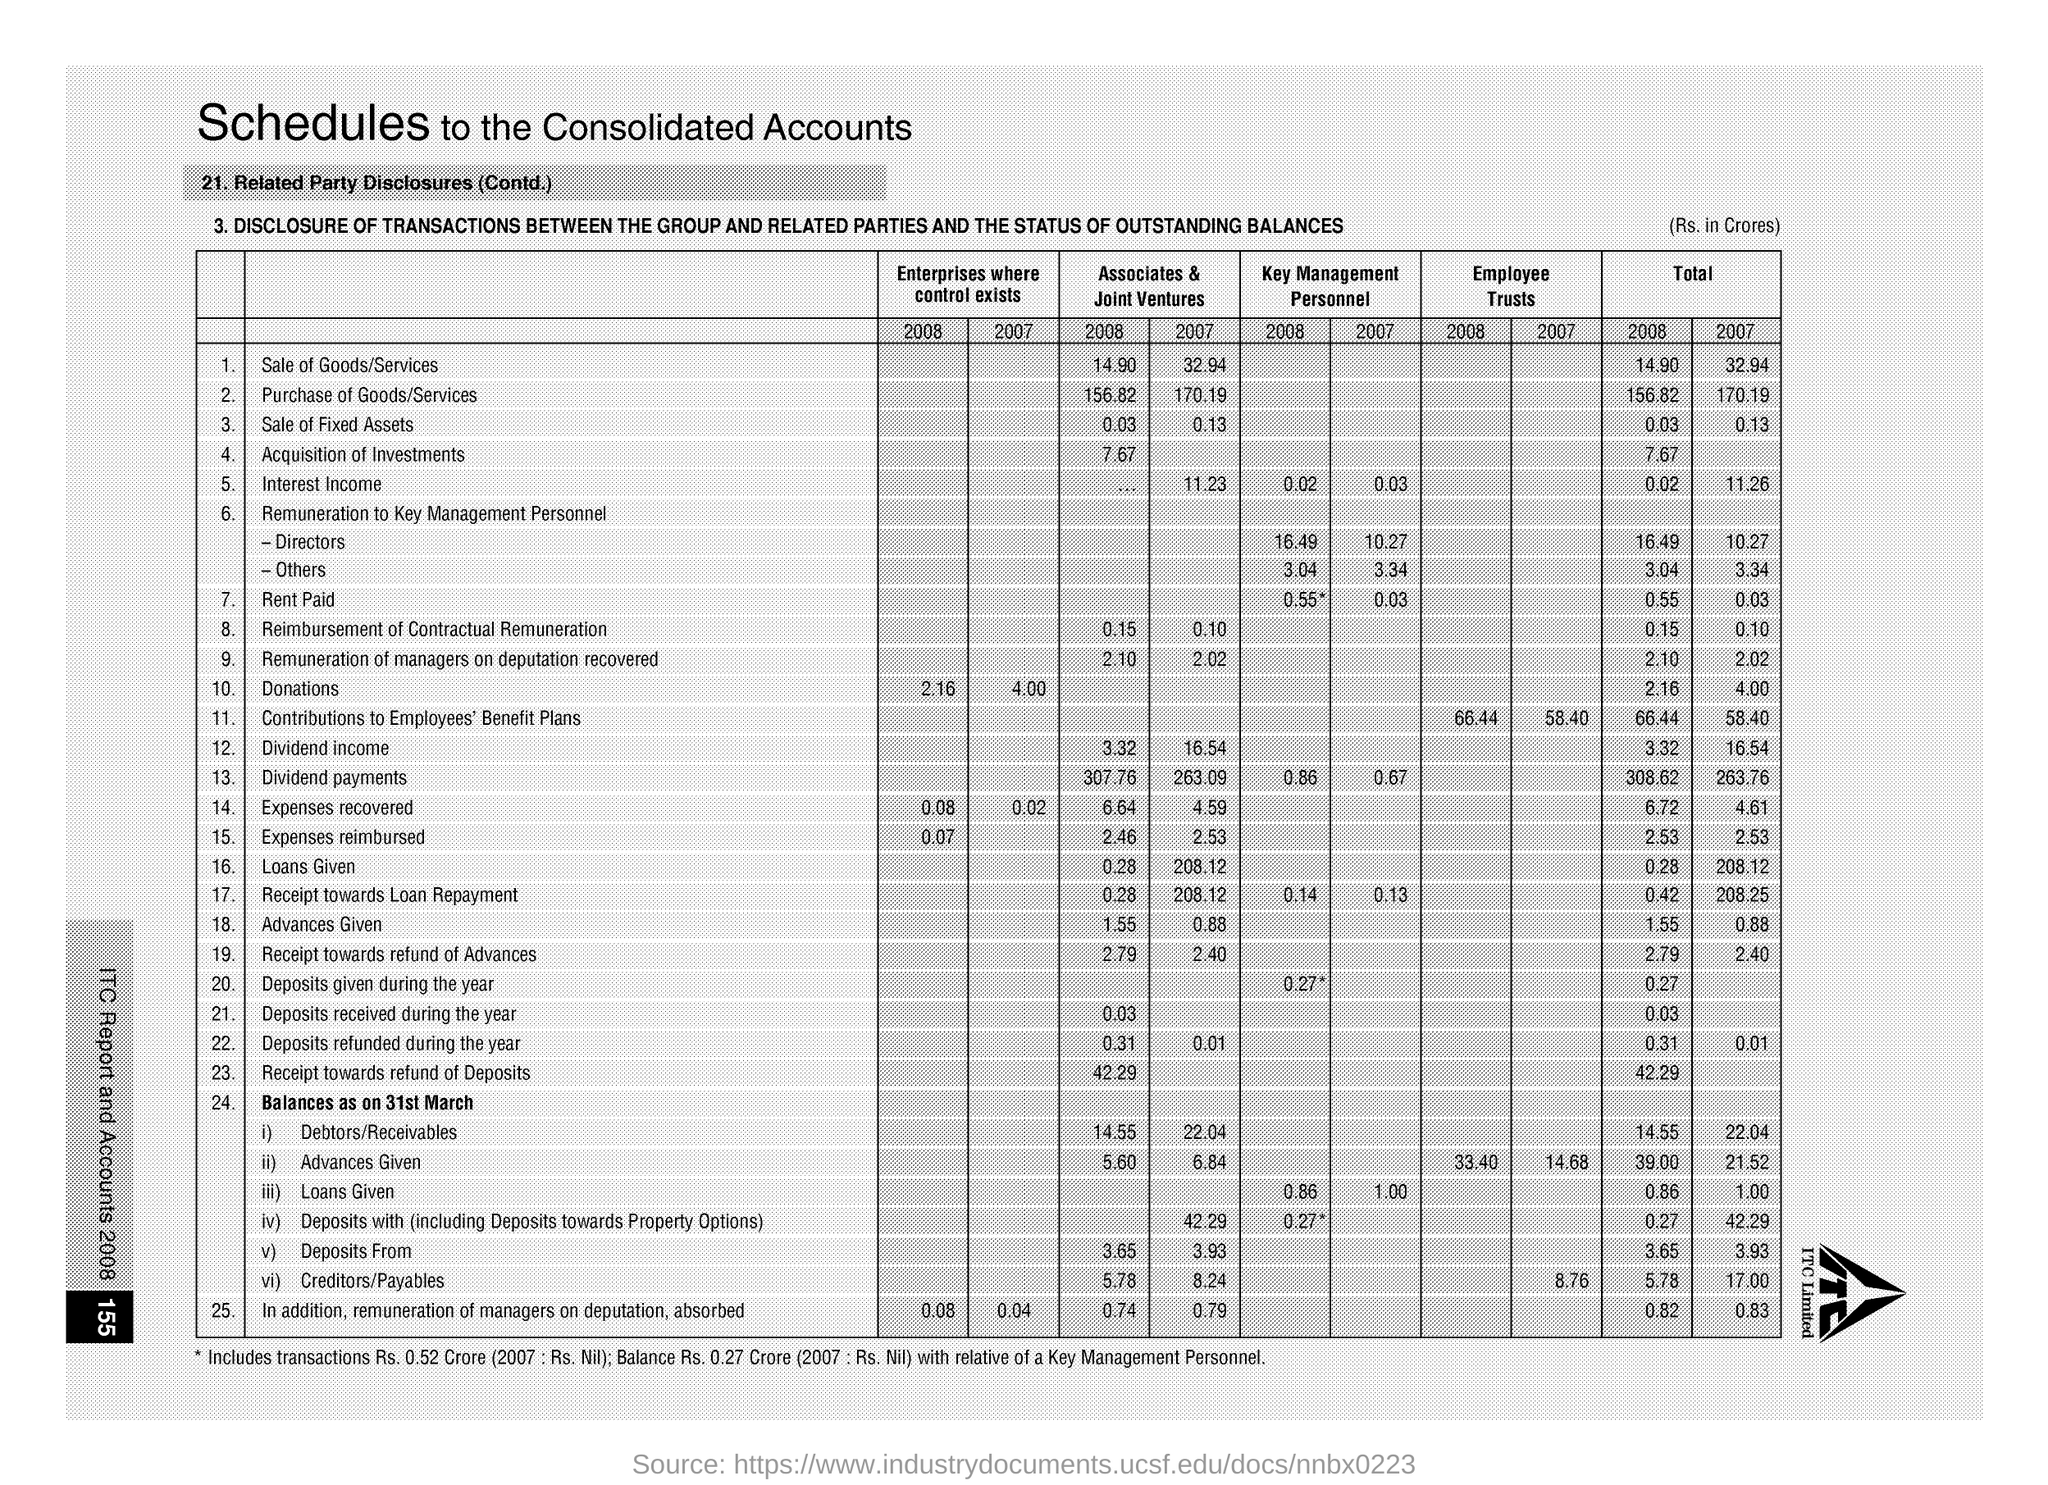What is the Total for Sale of Goods/Services for 2008?
Your answer should be compact. 14.90. What is the Total for Sale of Goods/Services for 2007?
Provide a short and direct response. 32.94. What is the Total for Purchase of Goods/Services for 2008?
Give a very brief answer. 156.82. What is the Total for Purchase of Goods/Services for 2007?
Provide a succinct answer. 170.19. What is the Total for Sale of Fixed Assets for 2008?
Your answer should be compact. 0.03. What is the Total for Sale of Fixed Assets for 2007?
Provide a succinct answer. 0.13. What is the Total for Rent Paid for 2008?
Your answer should be compact. 0.55. What is the Total for Rent Paid for 2007?
Your response must be concise. 0.03. What is the Total for Donations for 2008?
Give a very brief answer. 2.16. What is the Total for Donations for 2007?
Your answer should be compact. 4.00. 